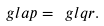Convert formula to latex. <formula><loc_0><loc_0><loc_500><loc_500>\ g l a p = \ g l q \sl r .</formula> 